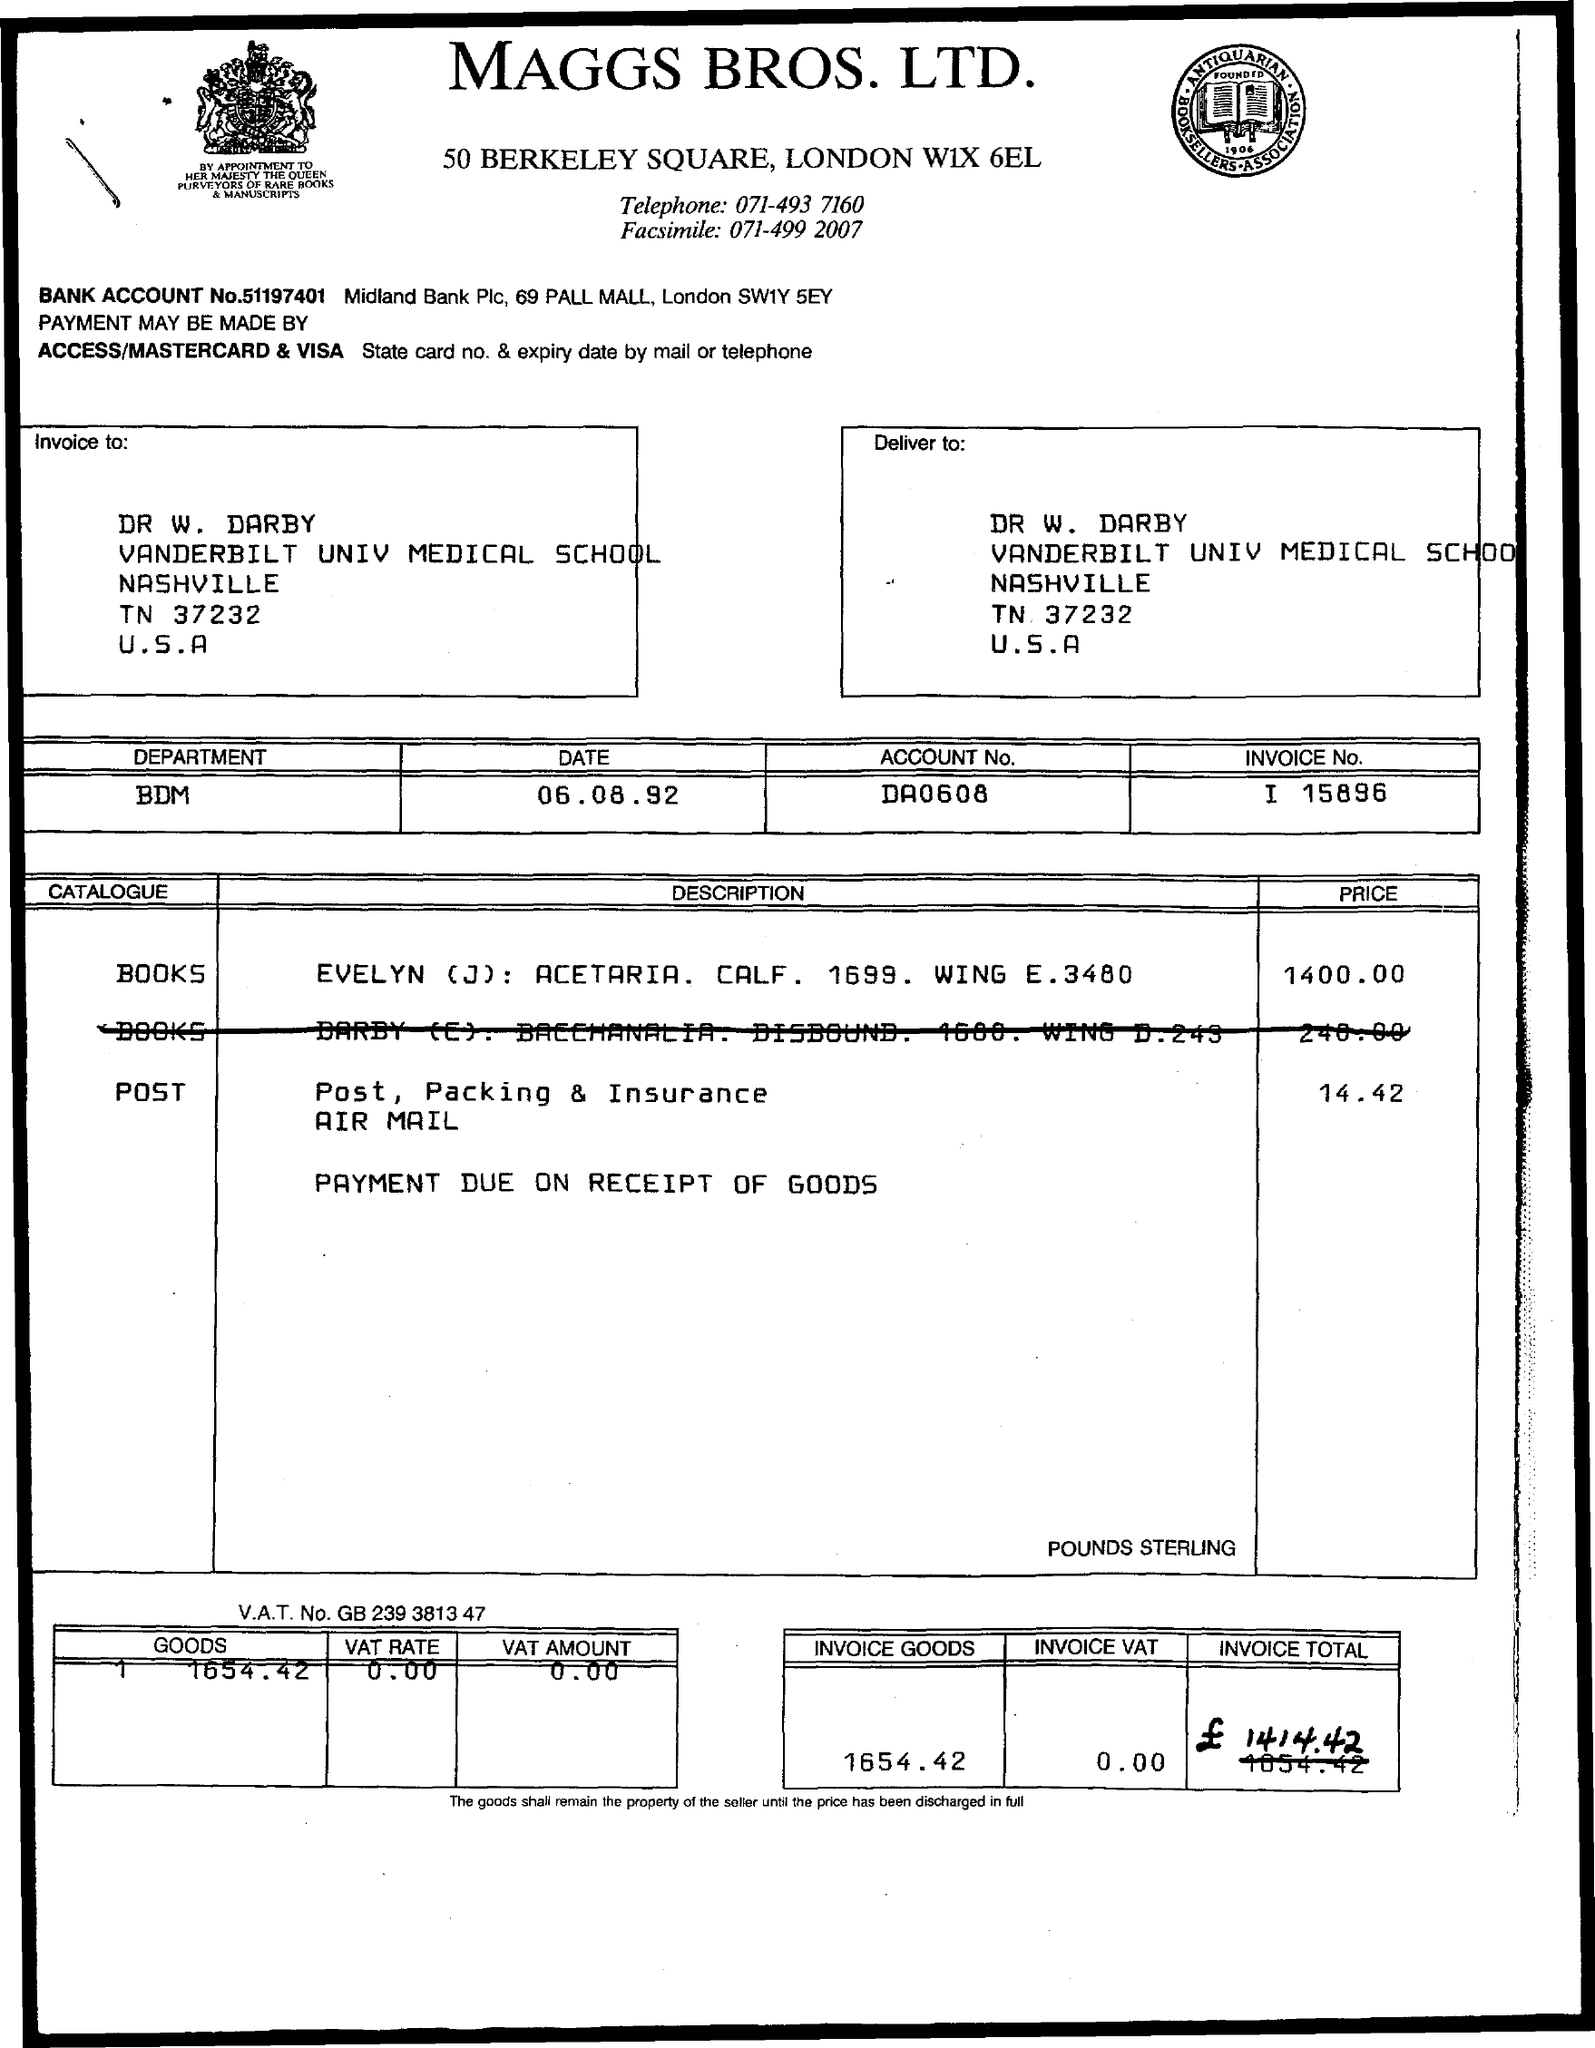What is the price of the post?
 14.42 